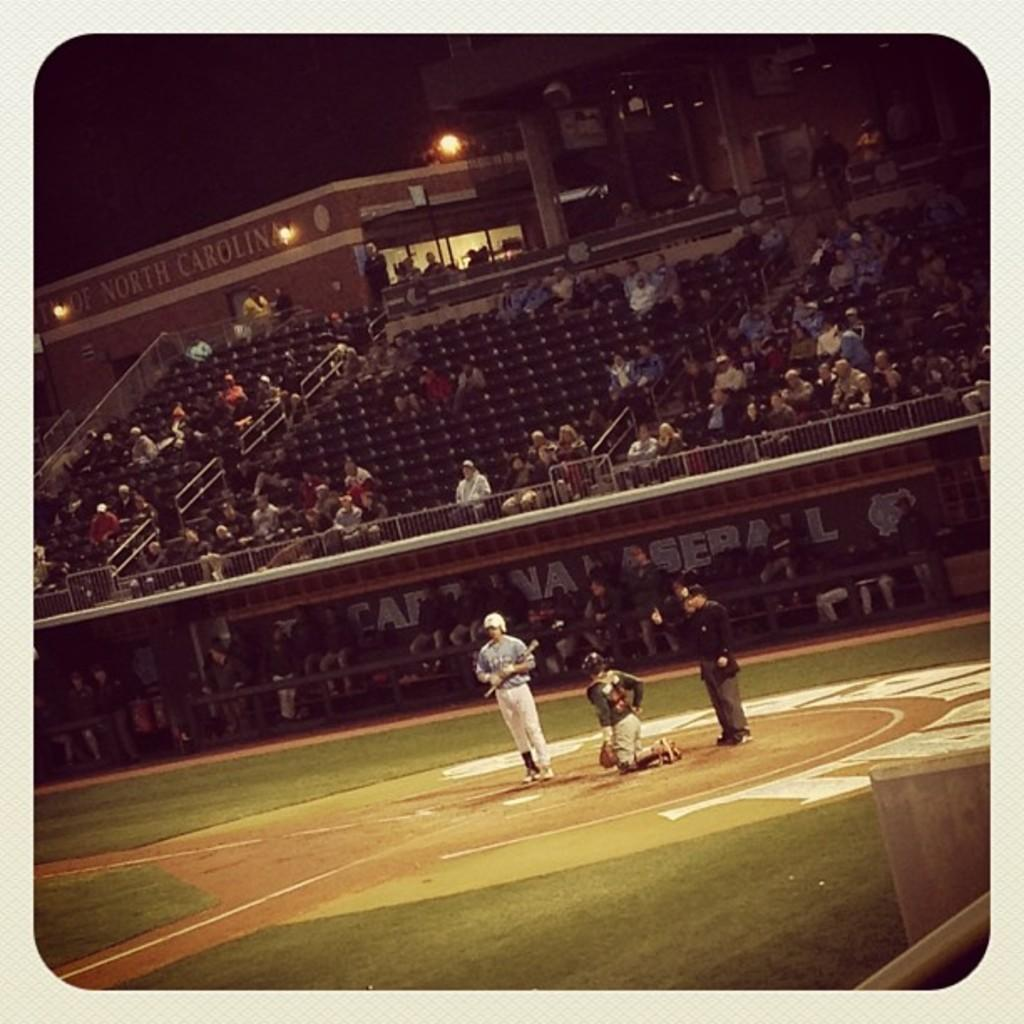<image>
Share a concise interpretation of the image provided. North Carolina and another team are playing a baseball game. 